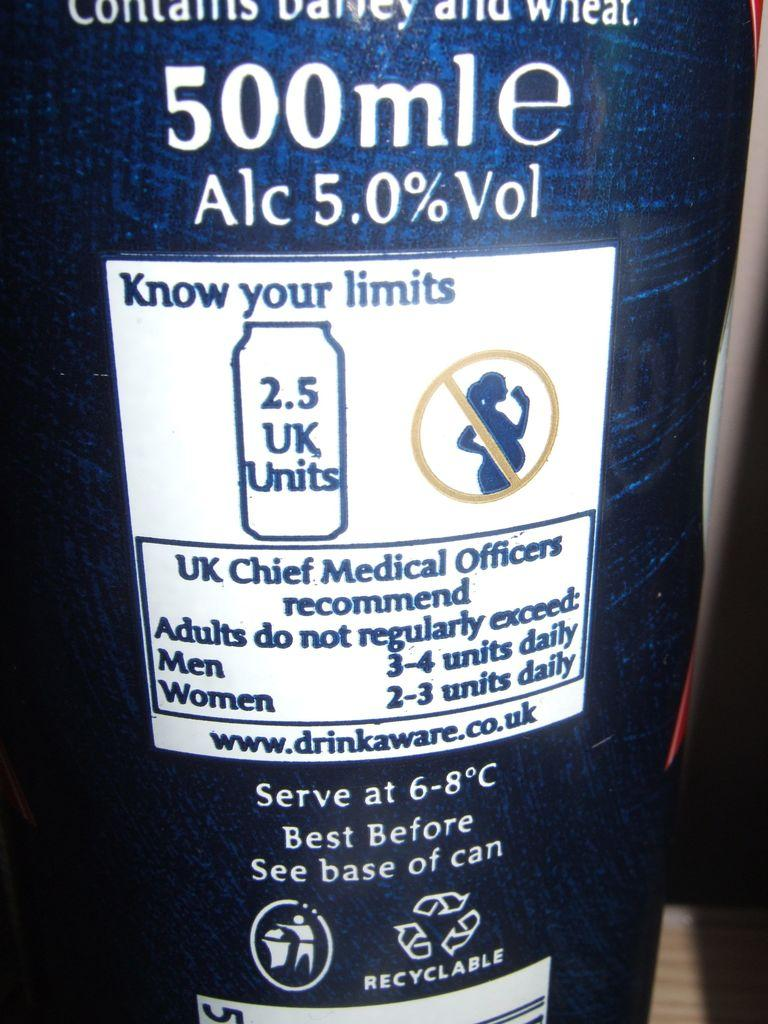<image>
Present a compact description of the photo's key features. Bottle of alcohol with a label saying to "Know Your Limits". 